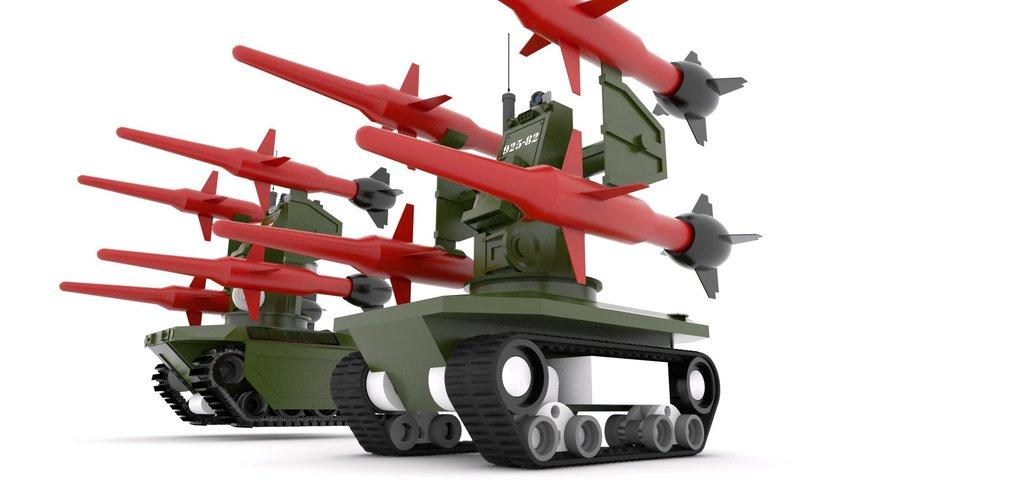What type of vehicles are present in the image? There are two battle tanks in the image. What can be observed about the background of the image? The background of the image appears to be white in color. What type of bird is participating in the discussion in the image? There is no bird or discussion present in the image; it features two battle tanks against a white background. 